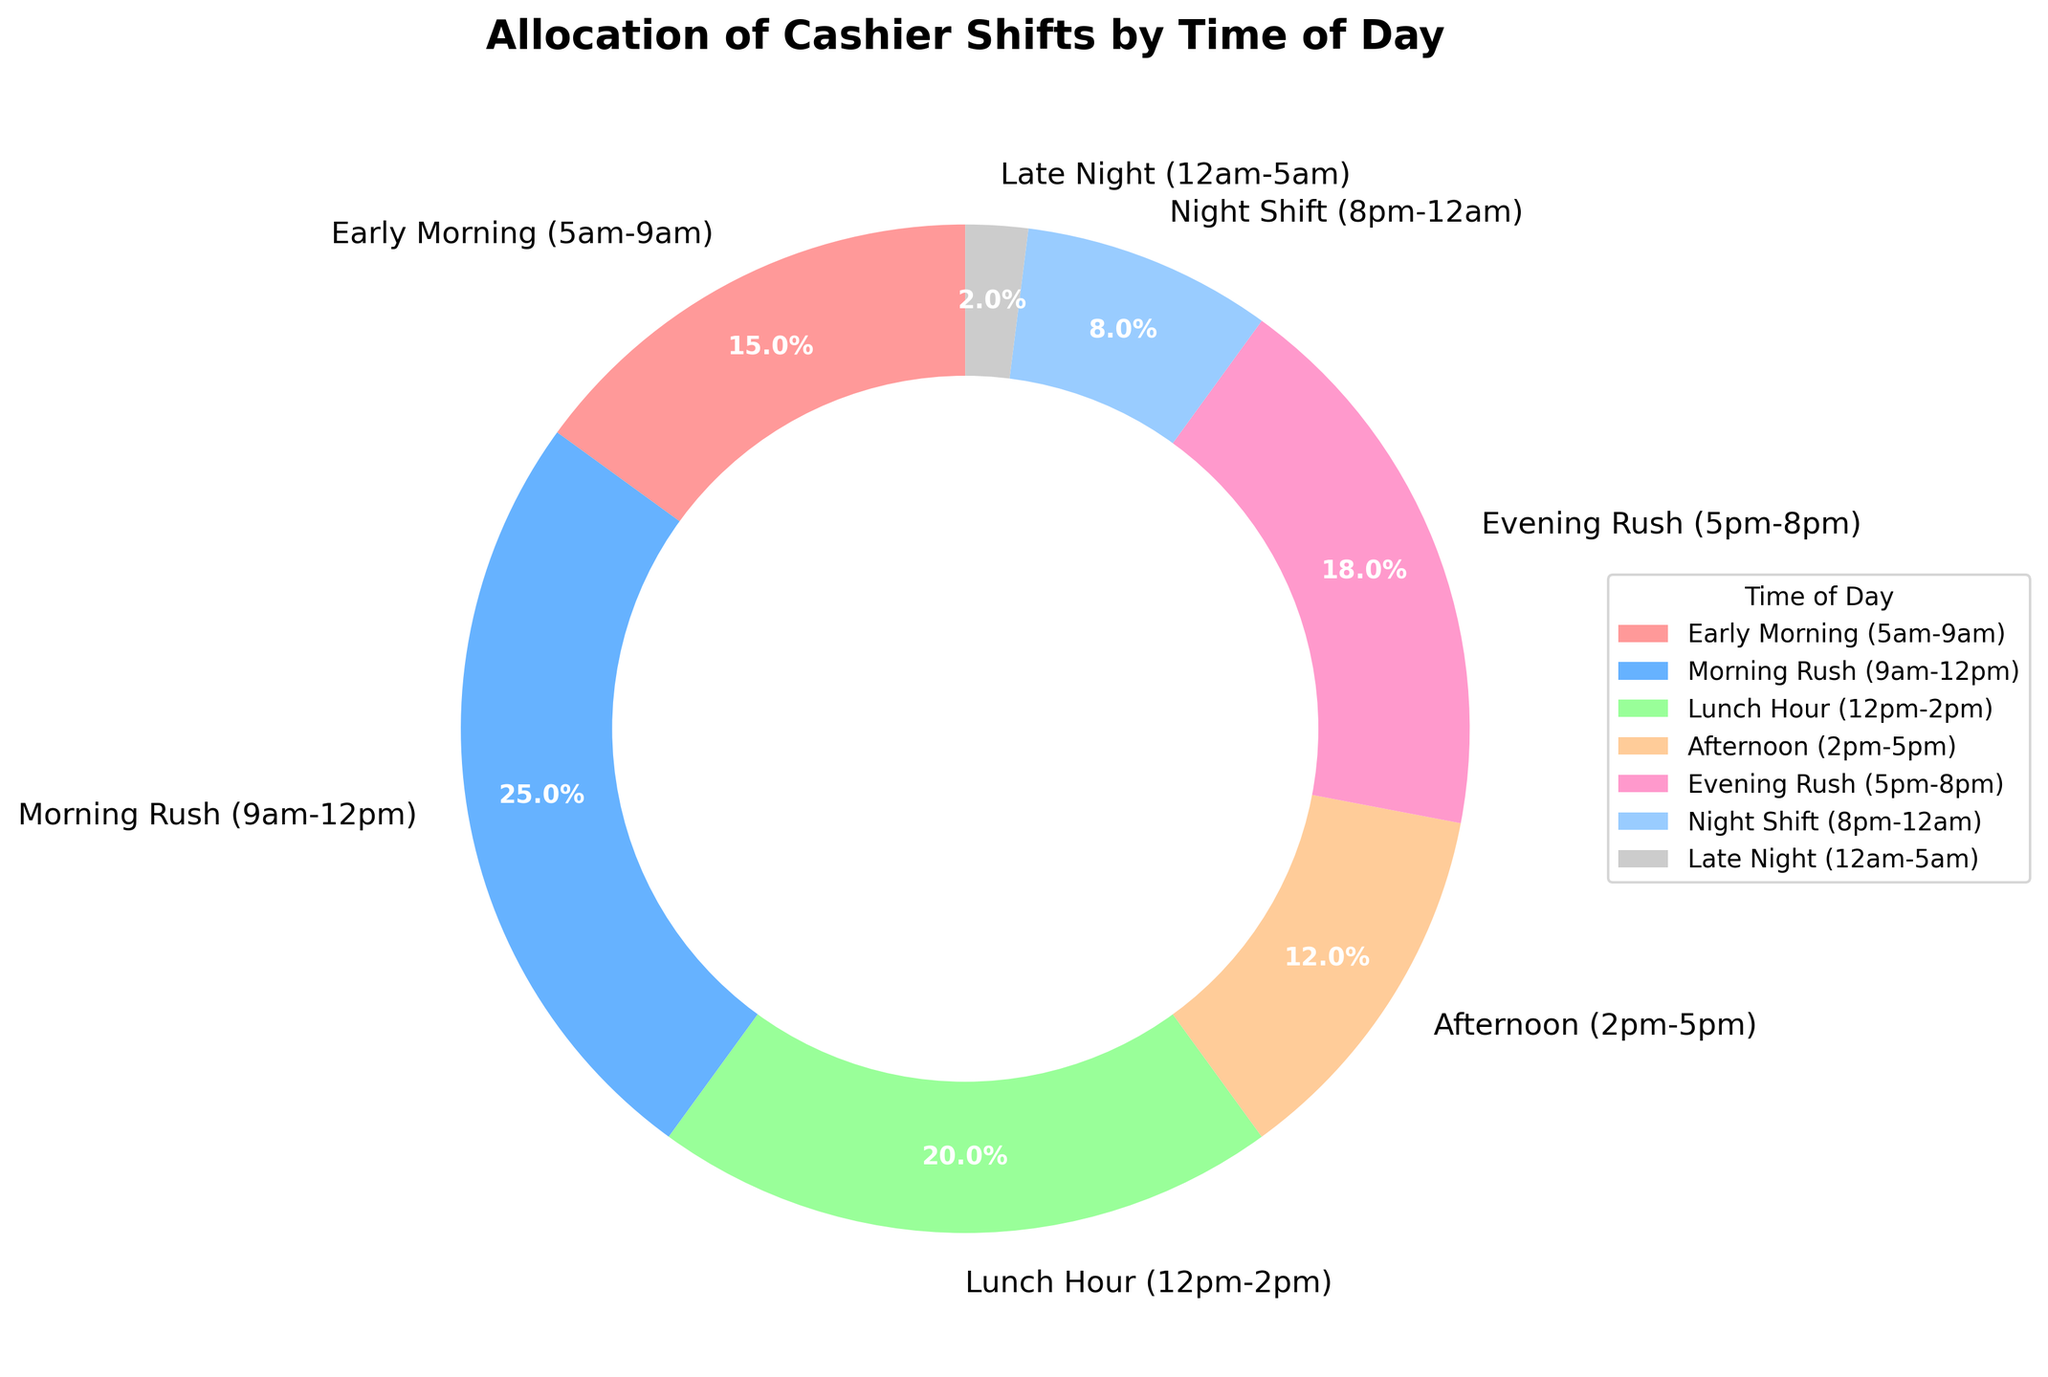Which time of day has the highest percentage of shifts covered? From the chart, the "Morning Rush (9am-12pm)" segment is the largest.
Answer: Morning Rush (9am-12pm) How much larger is the "Morning Rush" percentage compared to the "Night Shift"? The "Morning Rush" is 25%, while the "Night Shift" is 8%. The difference is 25% - 8% = 17%.
Answer: 17% What is the combined percentage of shifts covered during "Early Morning" and "Evening Rush"? The "Early Morning" is 15% and the "Evening Rush" is 18%. Combined, they are 15% + 18% = 33%.
Answer: 33% Which time of day has the smallest percentage of shifts covered? The chart shows that "Late Night (12am-5am)" has the smallest segment at 2%.
Answer: Late Night (12am-5am) What is the color of the "Lunch Hour" segment in the pie chart? The "Lunch Hour (12pm-2pm)" segment is colored green in the chart.
Answer: Green How does the "Afternoon" shift coverage compare to the "Night Shift"? The "Afternoon" has 12% coverage and the "Night Shift" has 8%. Thus, the "Afternoon" covers a higher percentage.
Answer: Afternoon What is the total percentage of shifts covered during both rush hours (Morning and Evening Rush)? "Morning Rush" is 25% and "Evening Rush" is 18%. Together, they cover 25% + 18% = 43%.
Answer: 43% Is the percentage of "Lunch Hour" shifts covered higher than that of "Evening Rush"? From the chart, "Lunch Hour (12pm-2pm)" is 20% and "Evening Rush (5pm-8pm)" is 18%. Since 20% > 18%, "Lunch Hour" is higher.
Answer: Yes What percentage of shifts are covered outside of traditional 9am-5pm working hours (including Early Morning, Night Shift, and Late Night)? Early Morning is 15%, Night Shift is 8%, and Late Night is 2%. Combined, it's 15% + 8% + 2% = 25%.
Answer: 25% What proportion of the total shifts is covered by the "Morning Rush" and "Afternoon" time periods combined? "Morning Rush" is 25% and "Afternoon" is 12%. Together, they cover 25% + 12% = 37%.
Answer: 37% 